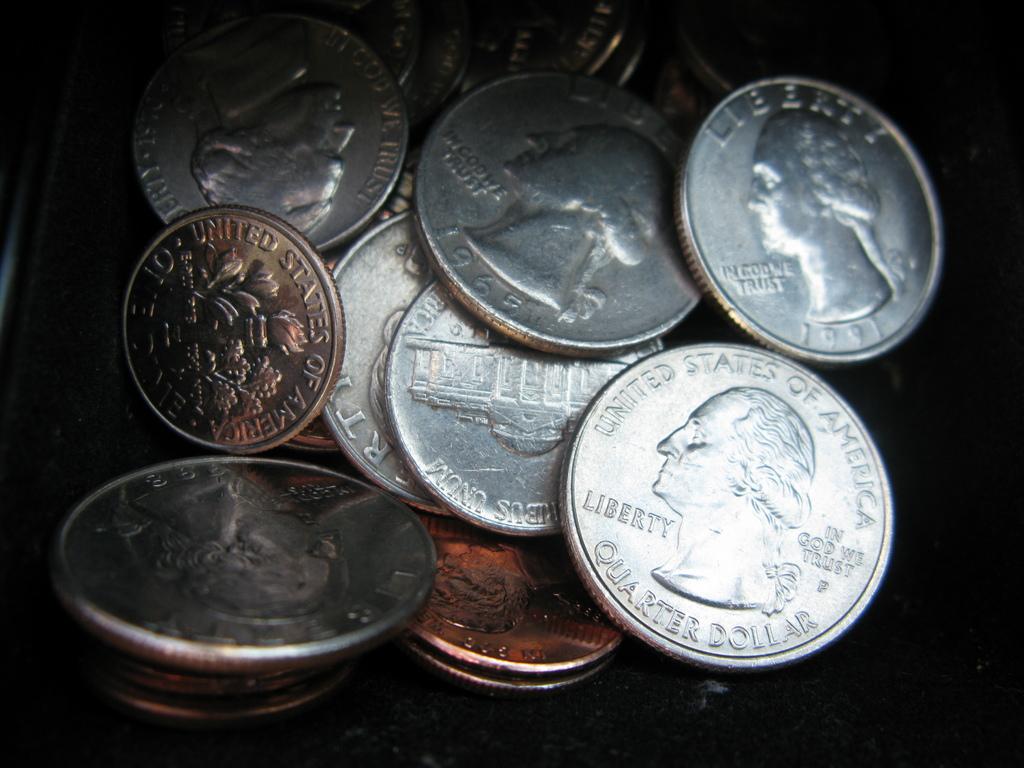What country is this currency from?
Offer a terse response. United states. 